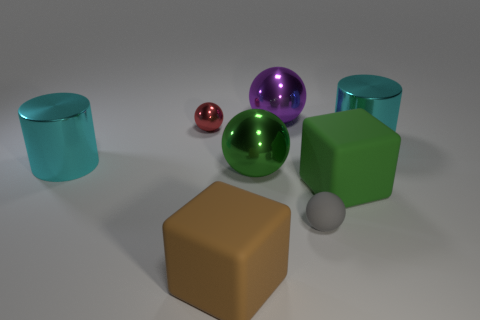Add 1 tiny yellow rubber balls. How many objects exist? 9 Subtract all small red spheres. How many spheres are left? 3 Subtract 1 cylinders. How many cylinders are left? 1 Subtract all red cylinders. Subtract all purple balls. How many cylinders are left? 2 Subtract all cyan balls. How many purple cylinders are left? 0 Subtract all gray shiny spheres. Subtract all large green cubes. How many objects are left? 7 Add 4 red metallic spheres. How many red metallic spheres are left? 5 Add 3 green rubber objects. How many green rubber objects exist? 4 Subtract all brown cubes. How many cubes are left? 1 Subtract 1 green balls. How many objects are left? 7 